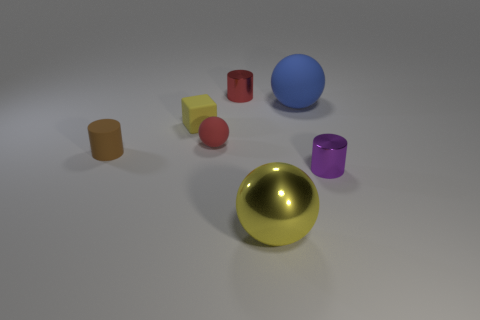Add 1 small yellow spheres. How many objects exist? 8 Subtract all cylinders. How many objects are left? 4 Subtract all large matte balls. Subtract all red shiny cylinders. How many objects are left? 5 Add 1 large yellow objects. How many large yellow objects are left? 2 Add 1 tiny red shiny cylinders. How many tiny red shiny cylinders exist? 2 Subtract 1 red cylinders. How many objects are left? 6 